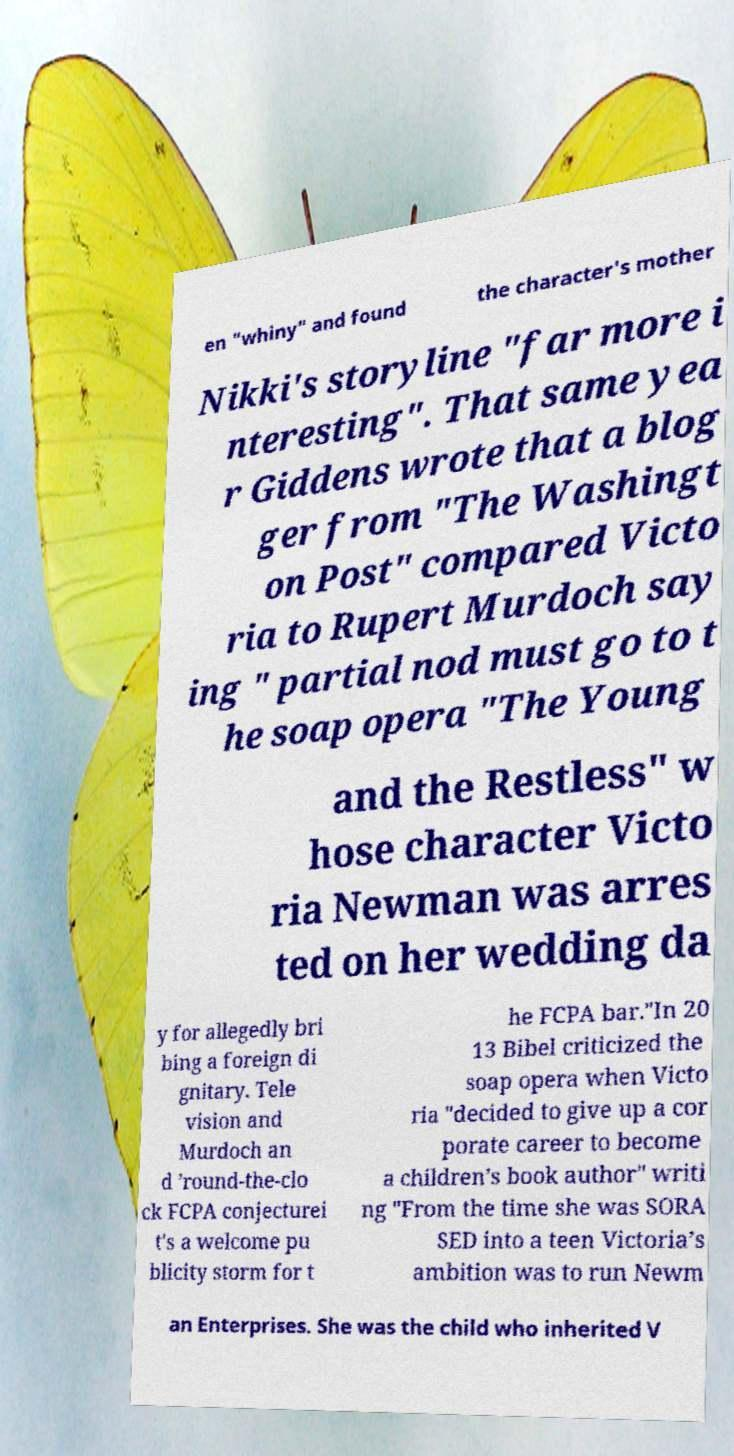Please identify and transcribe the text found in this image. en "whiny" and found the character's mother Nikki's storyline "far more i nteresting". That same yea r Giddens wrote that a blog ger from "The Washingt on Post" compared Victo ria to Rupert Murdoch say ing " partial nod must go to t he soap opera "The Young and the Restless" w hose character Victo ria Newman was arres ted on her wedding da y for allegedly bri bing a foreign di gnitary. Tele vision and Murdoch an d ’round-the-clo ck FCPA conjecturei t's a welcome pu blicity storm for t he FCPA bar."In 20 13 Bibel criticized the soap opera when Victo ria "decided to give up a cor porate career to become a children’s book author" writi ng "From the time she was SORA SED into a teen Victoria’s ambition was to run Newm an Enterprises. She was the child who inherited V 